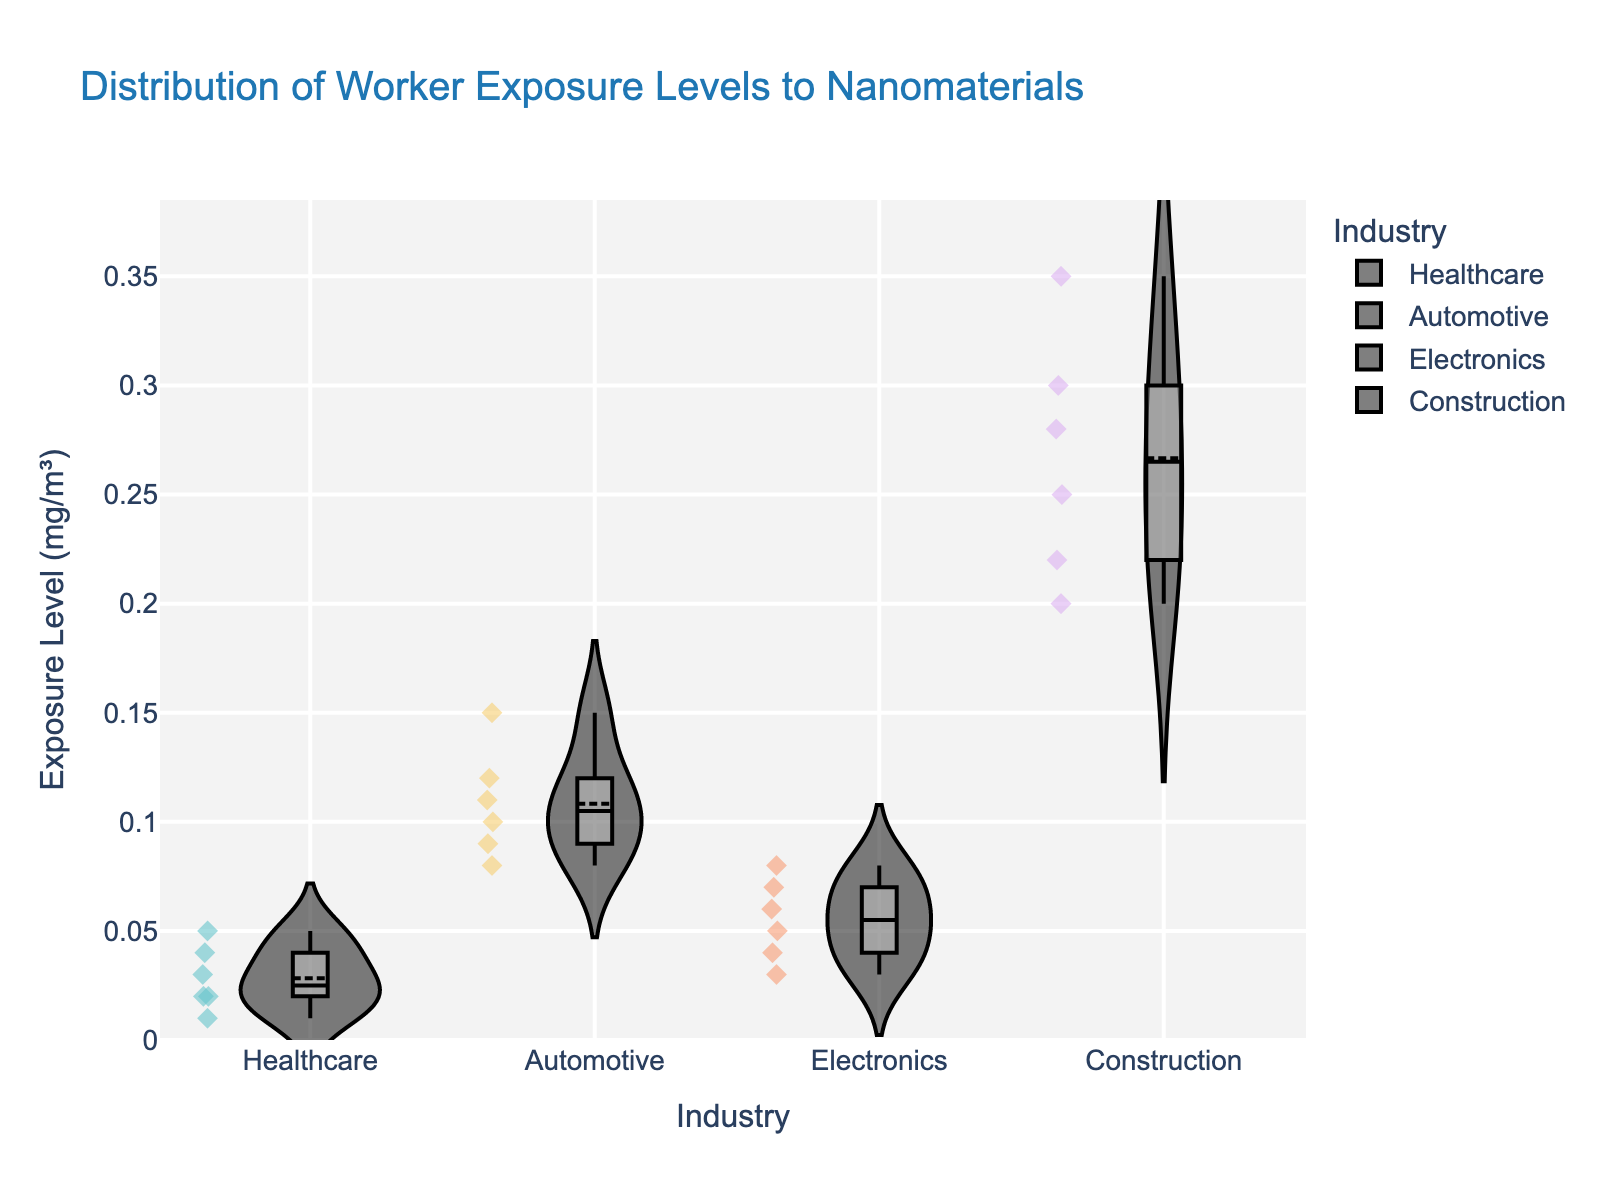What is the title of the figure? The title is typically located at the top of the figure and serves as a brief description of what the figure is about.
Answer: Distribution of Worker Exposure Levels to Nanomaterials Which industry has the highest maximum exposure level? The maximum exposure level for each industry can be seen by identifying the highest point within the violin plot for each industry. Construction industry shows the highest point.
Answer: Construction How does the median exposure level in the Healthcare industry compare to the median in the Automotive industry? The median exposure level is indicated by the line within the box displayed in each violin plot. By comparing these lines, it can be seen that the median value for Healthcare is lower than that for Automotive.
Answer: Lower Which industry has the widest spread in exposure levels? The spread can be gauged by the range of the violin plot. The industry with the longest range from minimum to maximum can be considered as the one with the widest spread. Construction has the widest spread.
Answer: Construction What is the range of exposure levels in the Electronics industry? The range is calculated by subtracting the minimum value from the maximum value within the violin plot for the Electronics industry.
Answer: 0.08 - 0.03 = 0.05 mg/m³ How many data points are there for the Construction industry? The number of data points can be counted by observing the individual points within the Construction industry's violin plot.
Answer: 6 Which industry has the most median exposure level? The median for each industry is represented by the line within the box. Construction industry has the highest line indicating the highest median.
Answer: Construction What is the mean exposure level in the Healthcare industry? The mean is typically shown by the mean line in the violin plot. By observing this line, we see the mean value.
Answer: 0.028 mg/m³ Do any industries have overlapping ranges of exposure levels? Overlapping ranges can be checked by comparing the extents of the violin plots for different industries. Healthcare and Electronics have overlapping exposure levels.
Answer: Yes, Healthcare and Electronics Which industry has a box inside the violin plot that has the smallest range? The box in the violin plot represents the interquartile range (IQR). The smallest IQR box indicates the least spread in the middle 50% of the data. Healthcare shows the smallest range box.
Answer: Healthcare 